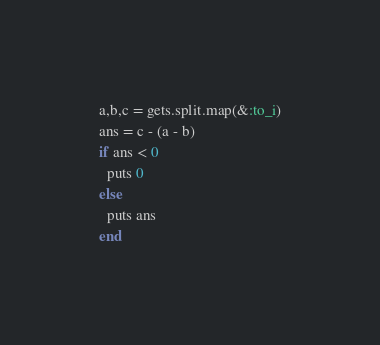<code> <loc_0><loc_0><loc_500><loc_500><_Ruby_>a,b,c = gets.split.map(&:to_i)
ans = c - (a - b)
if ans < 0
  puts 0
else
  puts ans
end
</code> 